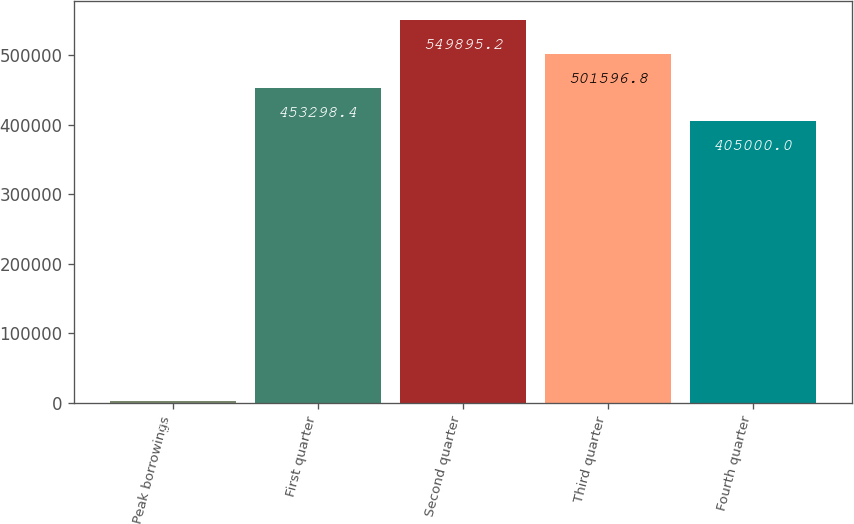Convert chart. <chart><loc_0><loc_0><loc_500><loc_500><bar_chart><fcel>Peak borrowings<fcel>First quarter<fcel>Second quarter<fcel>Third quarter<fcel>Fourth quarter<nl><fcel>2016<fcel>453298<fcel>549895<fcel>501597<fcel>405000<nl></chart> 